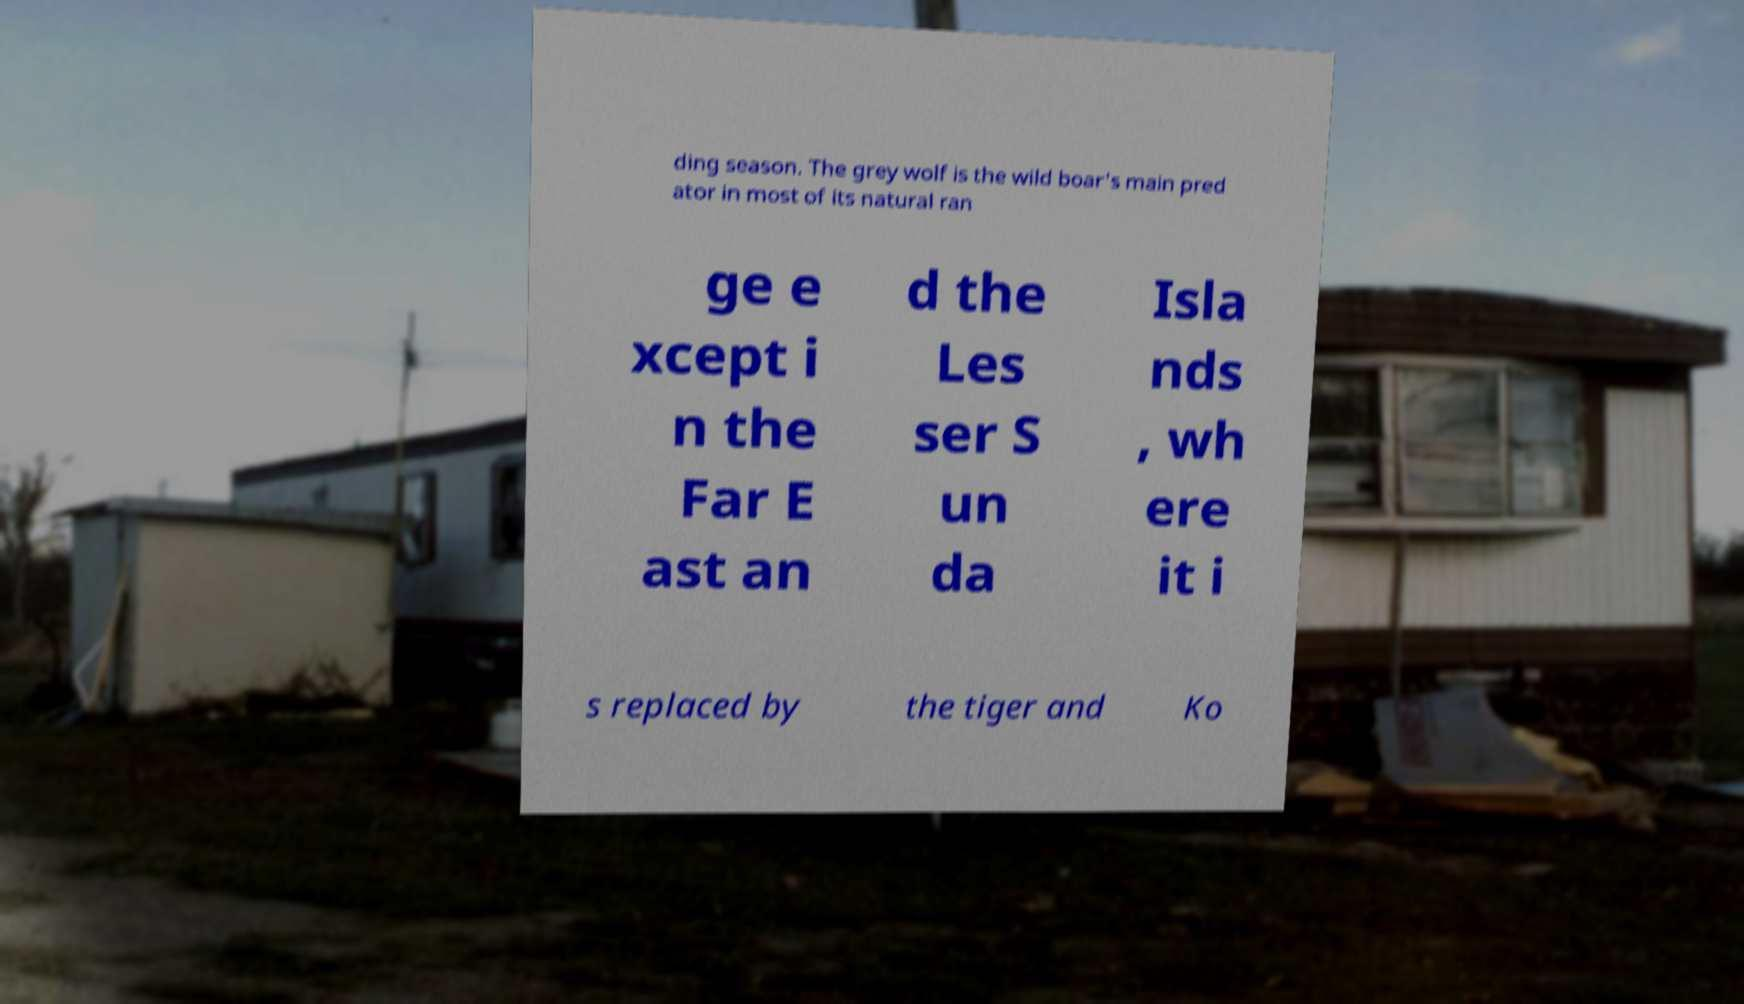There's text embedded in this image that I need extracted. Can you transcribe it verbatim? ding season. The grey wolf is the wild boar's main pred ator in most of its natural ran ge e xcept i n the Far E ast an d the Les ser S un da Isla nds , wh ere it i s replaced by the tiger and Ko 